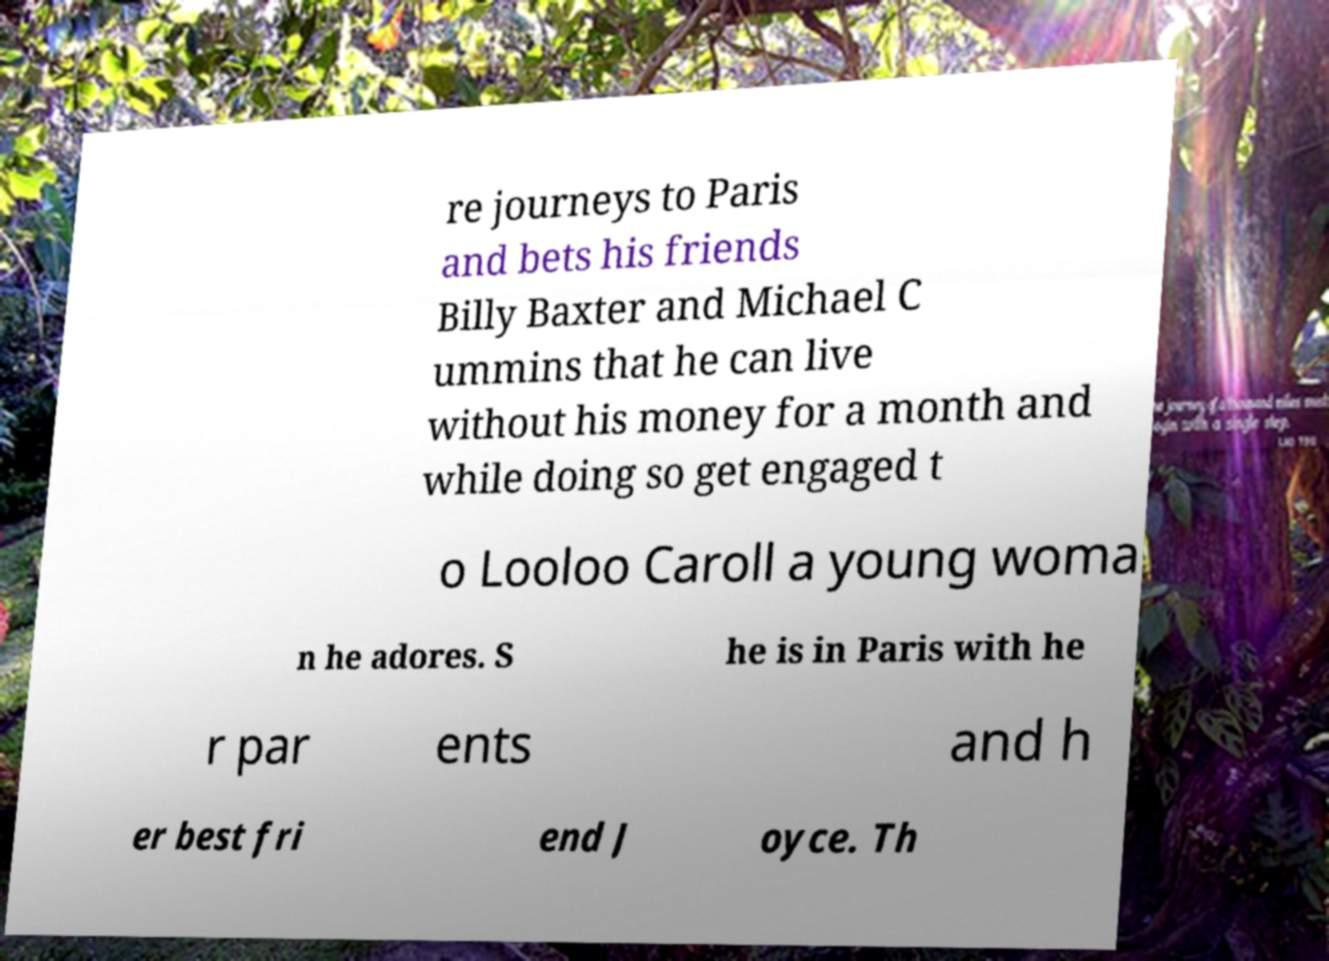For documentation purposes, I need the text within this image transcribed. Could you provide that? re journeys to Paris and bets his friends Billy Baxter and Michael C ummins that he can live without his money for a month and while doing so get engaged t o Looloo Caroll a young woma n he adores. S he is in Paris with he r par ents and h er best fri end J oyce. Th 